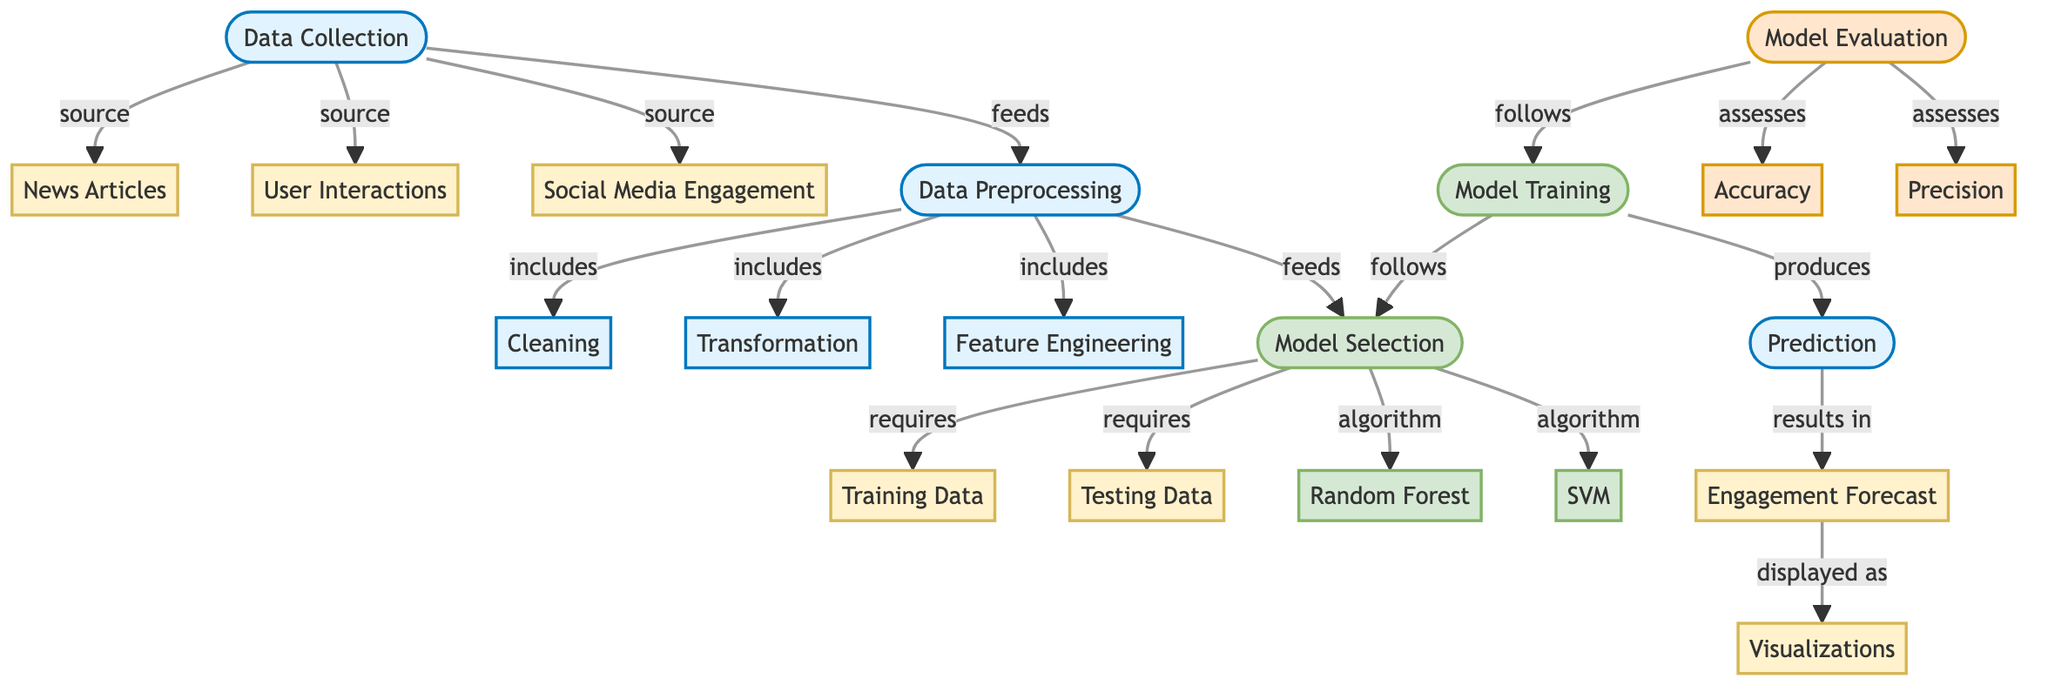What are the three types of data collected? The diagram lists three types of data: News Articles, User Interactions, and Social Media Engagement, which are all part of the Data Collection process.
Answer: News Articles, User Interactions, Social Media Engagement What follows after Data Preprocessing? The flowchart shows that after Data Preprocessing, the next step is Model Selection, meaning that the output from Data Preprocessing feeds directly into Model Selection.
Answer: Model Selection How many algorithms are used in Model Selection? The diagram shows two algorithms mentioned under Model Selection: Random Forest and SVM, indicating the total number of algorithms involved.
Answer: Two What is assessed during Model Evaluation? The diagram indicates that Model Evaluation is focused on two metrics: Accuracy and Precision, which determine the performance of the trained model.
Answer: Accuracy, Precision What is the relationship between Model Training and Prediction? The flowchart shows that Model Training produces Prediction as a direct output, meaning that without Model Training, there would be no Prediction generated.
Answer: Produces Which step displays the Engagement Forecast? The diagram points out that the final output of the model, Engagement Forecast, is displayed through Visualizations, establishing the connection between these two nodes.
Answer: Visualizations What are the processes included in Data Preprocessing? According to the diagram, Data Preprocessing includes three specific processes: Cleaning, Transformation, and Feature Engineering, all of which are essential to preparing data for modeling.
Answer: Cleaning, Transformation, Feature Engineering What type of models are included in Model Selection? The diagram specifies that the models for selection include Random Forest and SVM, indicating the category of models being considered in the predictive analysis.
Answer: Random Forest, SVM 